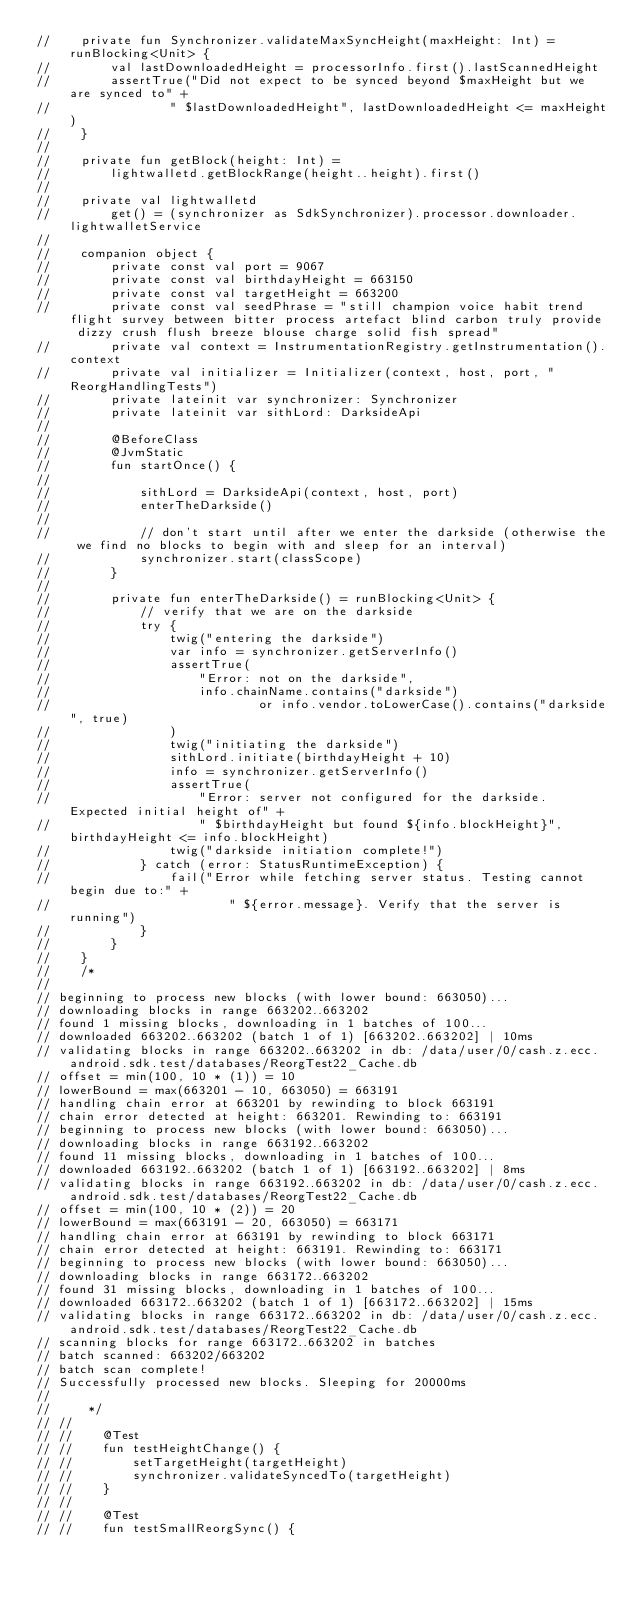<code> <loc_0><loc_0><loc_500><loc_500><_Kotlin_>//    private fun Synchronizer.validateMaxSyncHeight(maxHeight: Int) = runBlocking<Unit> {
//        val lastDownloadedHeight = processorInfo.first().lastScannedHeight
//        assertTrue("Did not expect to be synced beyond $maxHeight but we are synced to" +
//                " $lastDownloadedHeight", lastDownloadedHeight <= maxHeight)
//    }
//
//    private fun getBlock(height: Int) =
//        lightwalletd.getBlockRange(height..height).first()
//
//    private val lightwalletd
//        get() = (synchronizer as SdkSynchronizer).processor.downloader.lightwalletService
//
//    companion object {
//        private const val port = 9067
//        private const val birthdayHeight = 663150
//        private const val targetHeight = 663200
//        private const val seedPhrase = "still champion voice habit trend flight survey between bitter process artefact blind carbon truly provide dizzy crush flush breeze blouse charge solid fish spread"
//        private val context = InstrumentationRegistry.getInstrumentation().context
//        private val initializer = Initializer(context, host, port, "ReorgHandlingTests")
//        private lateinit var synchronizer: Synchronizer
//        private lateinit var sithLord: DarksideApi
//
//        @BeforeClass
//        @JvmStatic
//        fun startOnce() {
//
//            sithLord = DarksideApi(context, host, port)
//            enterTheDarkside()
//
//            // don't start until after we enter the darkside (otherwise the we find no blocks to begin with and sleep for an interval)
//            synchronizer.start(classScope)
//        }
//
//        private fun enterTheDarkside() = runBlocking<Unit> {
//            // verify that we are on the darkside
//            try {
//                twig("entering the darkside")
//                var info = synchronizer.getServerInfo()
//                assertTrue(
//                    "Error: not on the darkside",
//                    info.chainName.contains("darkside")
//                            or info.vendor.toLowerCase().contains("darkside", true)
//                )
//                twig("initiating the darkside")
//                sithLord.initiate(birthdayHeight + 10)
//                info = synchronizer.getServerInfo()
//                assertTrue(
//                    "Error: server not configured for the darkside. Expected initial height of" +
//                    " $birthdayHeight but found ${info.blockHeight}", birthdayHeight <= info.blockHeight)
//                twig("darkside initiation complete!")
//            } catch (error: StatusRuntimeException) {
//                fail("Error while fetching server status. Testing cannot begin due to:" +
//                        " ${error.message}. Verify that the server is running")
//            }
//        }
//    }
//    /*
//
// beginning to process new blocks (with lower bound: 663050)...
// downloading blocks in range 663202..663202
// found 1 missing blocks, downloading in 1 batches of 100...
// downloaded 663202..663202 (batch 1 of 1) [663202..663202] | 10ms
// validating blocks in range 663202..663202 in db: /data/user/0/cash.z.ecc.android.sdk.test/databases/ReorgTest22_Cache.db
// offset = min(100, 10 * (1)) = 10
// lowerBound = max(663201 - 10, 663050) = 663191
// handling chain error at 663201 by rewinding to block 663191
// chain error detected at height: 663201. Rewinding to: 663191
// beginning to process new blocks (with lower bound: 663050)...
// downloading blocks in range 663192..663202
// found 11 missing blocks, downloading in 1 batches of 100...
// downloaded 663192..663202 (batch 1 of 1) [663192..663202] | 8ms
// validating blocks in range 663192..663202 in db: /data/user/0/cash.z.ecc.android.sdk.test/databases/ReorgTest22_Cache.db
// offset = min(100, 10 * (2)) = 20
// lowerBound = max(663191 - 20, 663050) = 663171
// handling chain error at 663191 by rewinding to block 663171
// chain error detected at height: 663191. Rewinding to: 663171
// beginning to process new blocks (with lower bound: 663050)...
// downloading blocks in range 663172..663202
// found 31 missing blocks, downloading in 1 batches of 100...
// downloaded 663172..663202 (batch 1 of 1) [663172..663202] | 15ms
// validating blocks in range 663172..663202 in db: /data/user/0/cash.z.ecc.android.sdk.test/databases/ReorgTest22_Cache.db
// scanning blocks for range 663172..663202 in batches
// batch scanned: 663202/663202
// batch scan complete!
// Successfully processed new blocks. Sleeping for 20000ms
//
//     */
// //
// //    @Test
// //    fun testHeightChange() {
// //        setTargetHeight(targetHeight)
// //        synchronizer.validateSyncedTo(targetHeight)
// //    }
// //
// //    @Test
// //    fun testSmallReorgSync() {</code> 